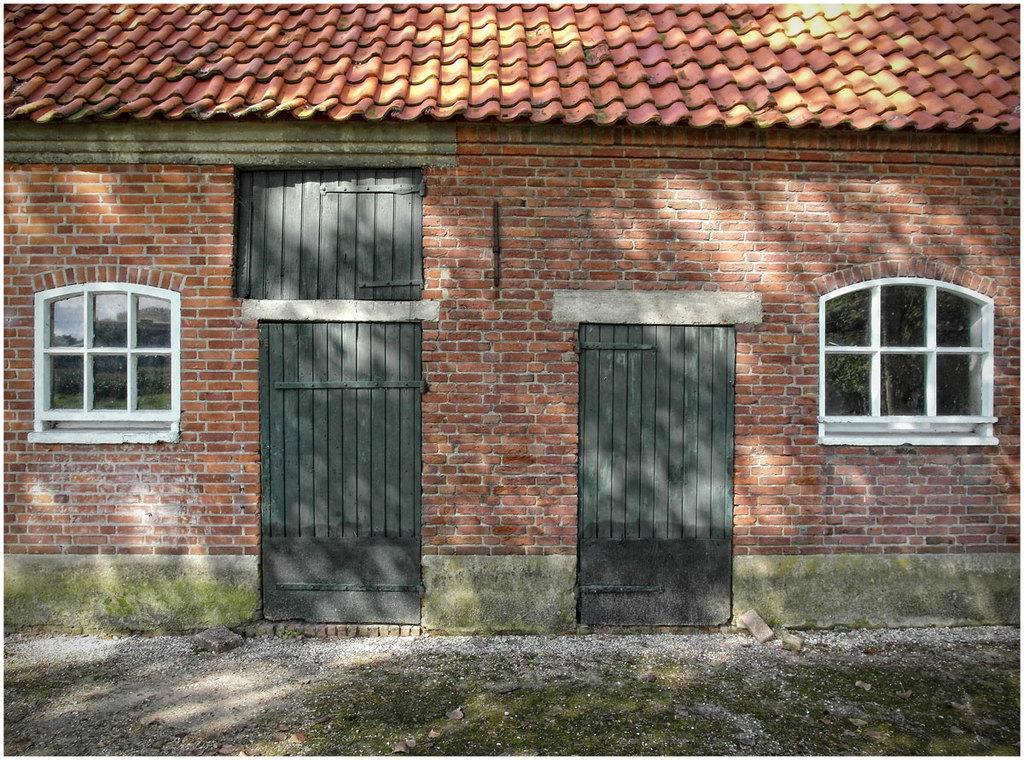Please provide a concise description of this image. In this image there is a building which is red in colour and there are doors and windows. 